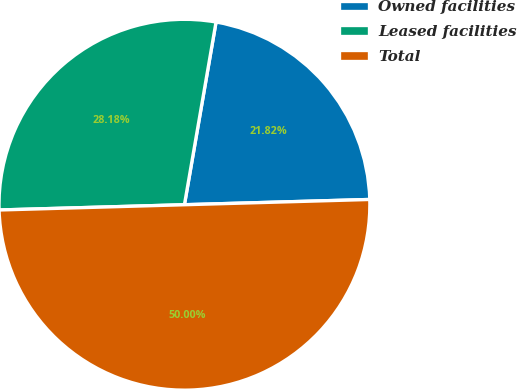Convert chart to OTSL. <chart><loc_0><loc_0><loc_500><loc_500><pie_chart><fcel>Owned facilities<fcel>Leased facilities<fcel>Total<nl><fcel>21.82%<fcel>28.18%<fcel>50.0%<nl></chart> 